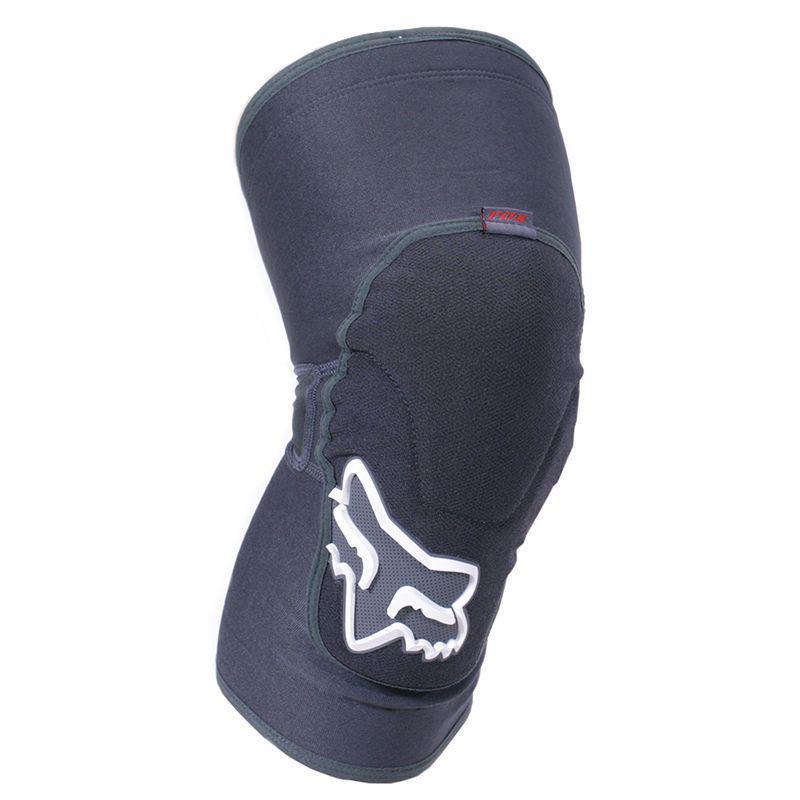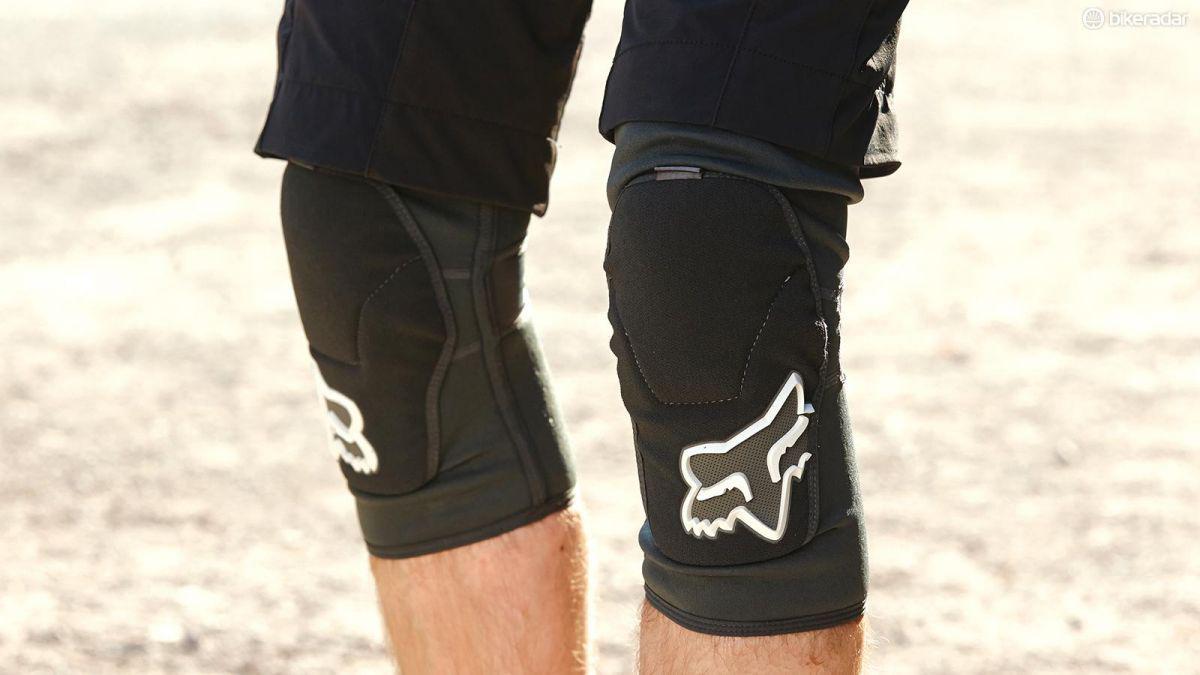The first image is the image on the left, the second image is the image on the right. Analyze the images presented: Is the assertion "All of the images contain only one knee guard." valid? Answer yes or no. No. The first image is the image on the left, the second image is the image on the right. For the images shown, is this caption "One image shows what the back side of the knee pad looks like." true? Answer yes or no. No. 